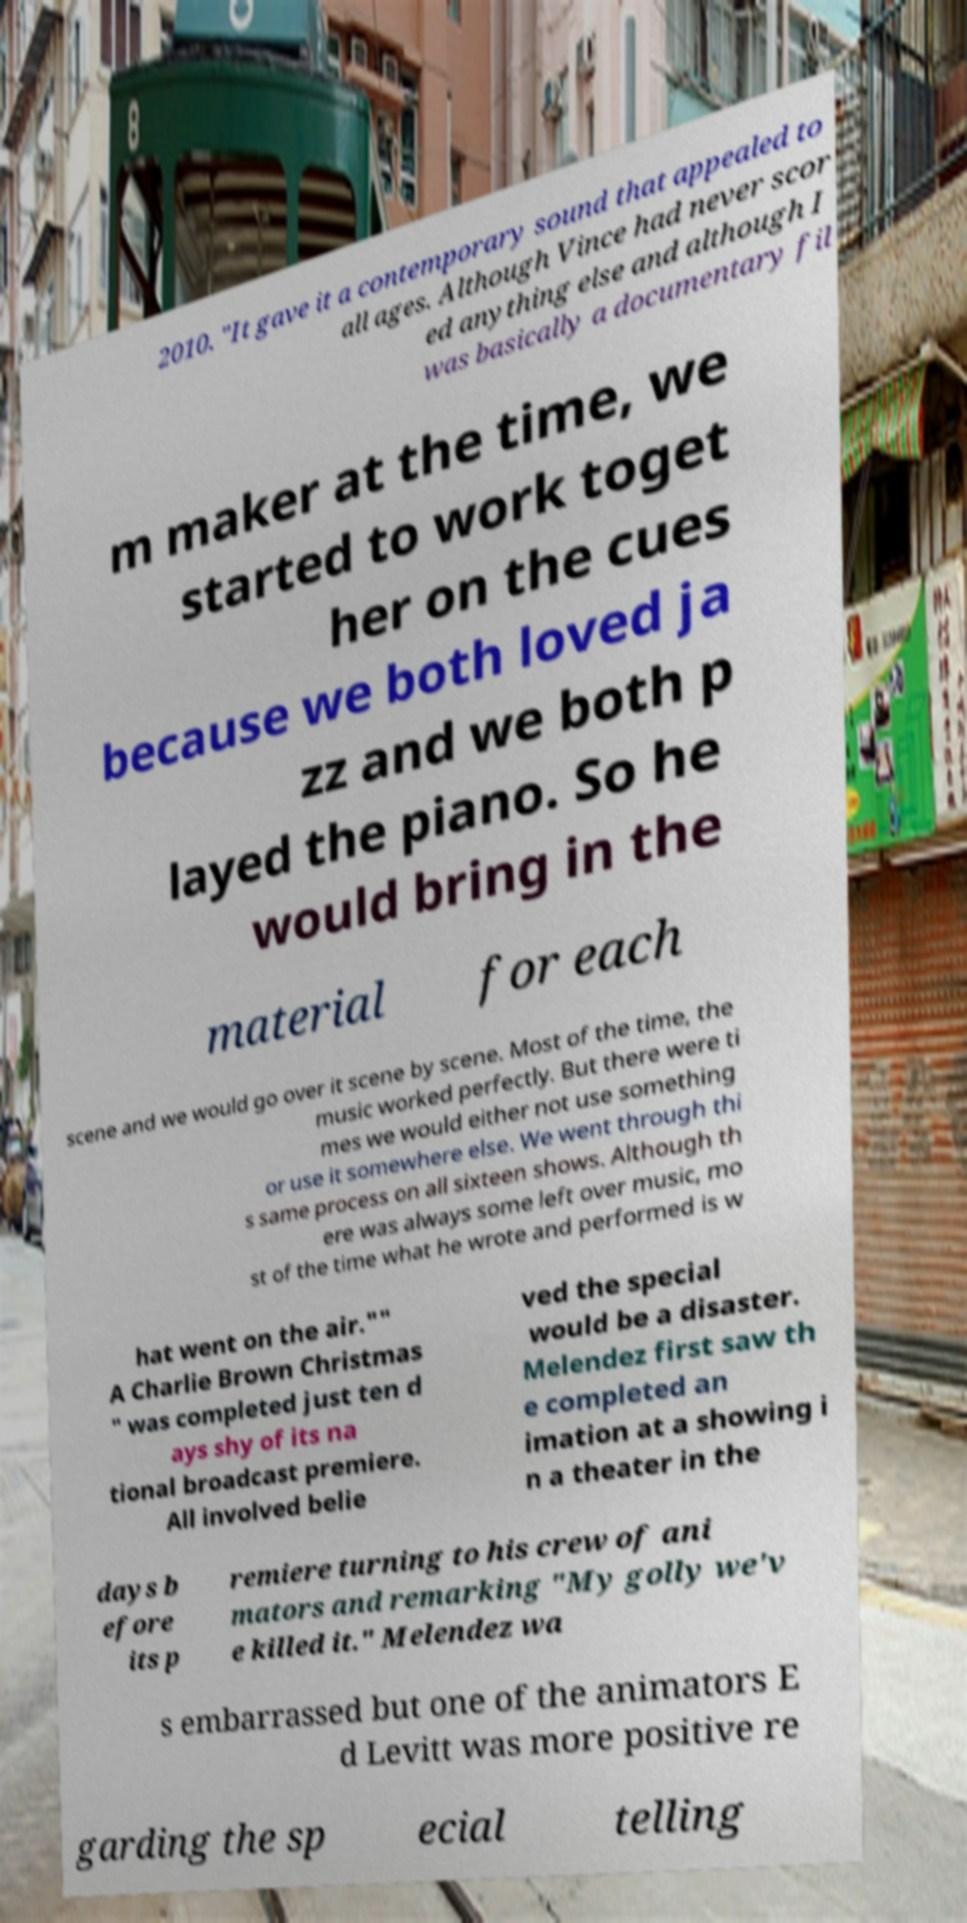For documentation purposes, I need the text within this image transcribed. Could you provide that? 2010. "It gave it a contemporary sound that appealed to all ages. Although Vince had never scor ed anything else and although I was basically a documentary fil m maker at the time, we started to work toget her on the cues because we both loved ja zz and we both p layed the piano. So he would bring in the material for each scene and we would go over it scene by scene. Most of the time, the music worked perfectly. But there were ti mes we would either not use something or use it somewhere else. We went through thi s same process on all sixteen shows. Although th ere was always some left over music, mo st of the time what he wrote and performed is w hat went on the air."" A Charlie Brown Christmas " was completed just ten d ays shy of its na tional broadcast premiere. All involved belie ved the special would be a disaster. Melendez first saw th e completed an imation at a showing i n a theater in the days b efore its p remiere turning to his crew of ani mators and remarking "My golly we'v e killed it." Melendez wa s embarrassed but one of the animators E d Levitt was more positive re garding the sp ecial telling 